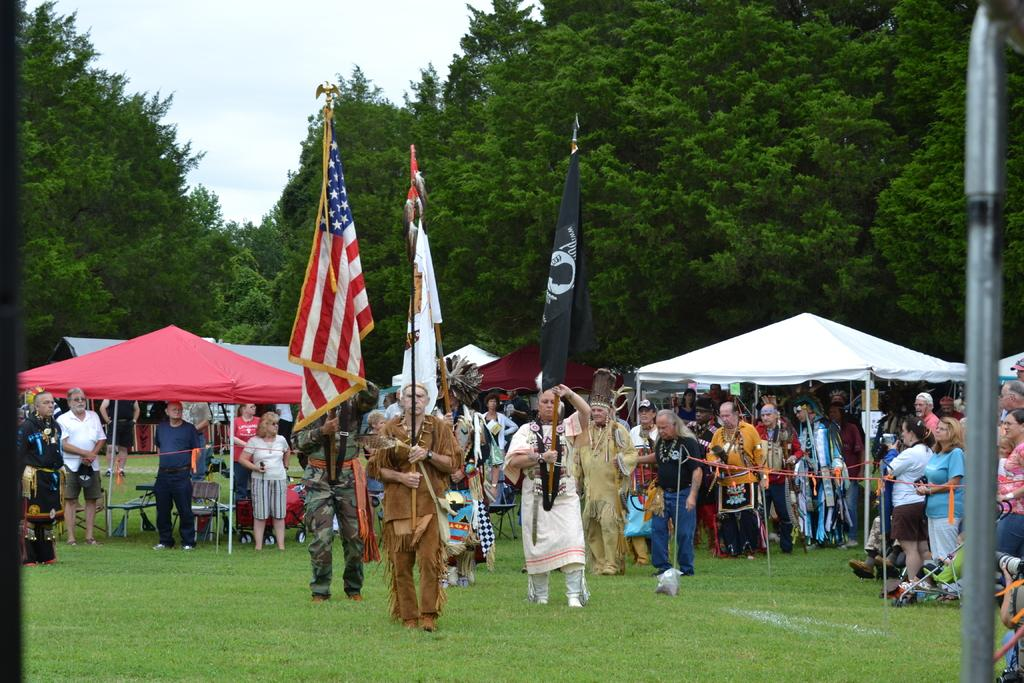What type of structures are visible in the image? There are sheds in the image. Who or what can be seen in the image? There are people in the image. What decorative or symbolic objects are present in the image? There are flags in the image. What type of temporary structures are visible in the image? There are stands in the image. What type of material is present in the image? There is a rope in the image. What type of vegetation is visible in the image? There are trees in the image. What type of ground cover is visible in the image? There is grass in the image. What is visible in the background of the image? The sky is visible in the background. What type of sack can be seen in the image? There is no sack present in the image. 